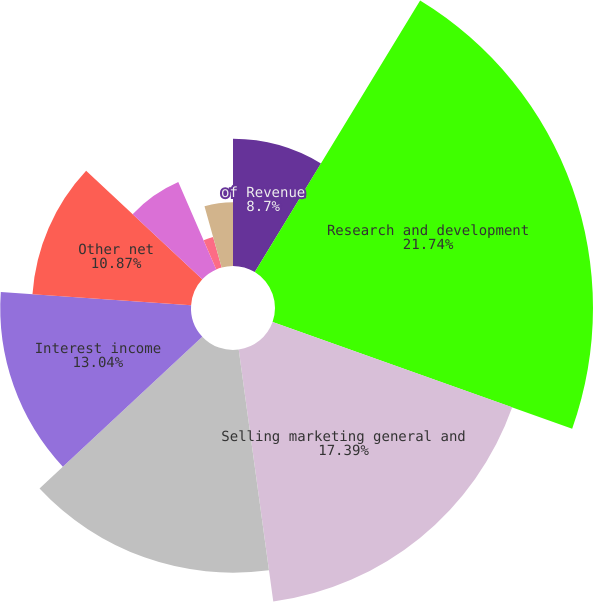<chart> <loc_0><loc_0><loc_500><loc_500><pie_chart><fcel>of Revenue<fcel>Research and development<fcel>Selling marketing general and<fcel>Interest expense<fcel>Interest income<fcel>Other net<fcel>Total nonoperating (income)<fcel>Income from continuing<fcel>Net income<fcel>Dividends declared per share<nl><fcel>8.7%<fcel>21.74%<fcel>17.39%<fcel>15.22%<fcel>13.04%<fcel>10.87%<fcel>6.52%<fcel>2.17%<fcel>4.35%<fcel>0.0%<nl></chart> 